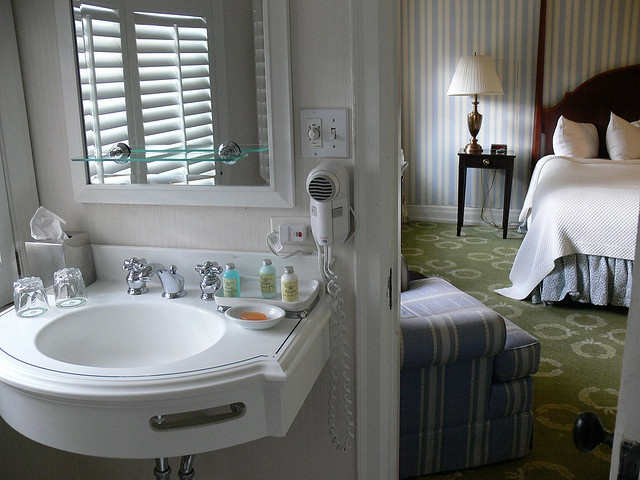Describe the objects in this image and their specific colors. I can see bed in gray, lightgray, black, and darkgray tones, chair in gray, black, and darkgray tones, sink in gray, darkgray, and lightgray tones, hair drier in gray, darkgray, and black tones, and bowl in gray, darkgray, and lightgray tones in this image. 